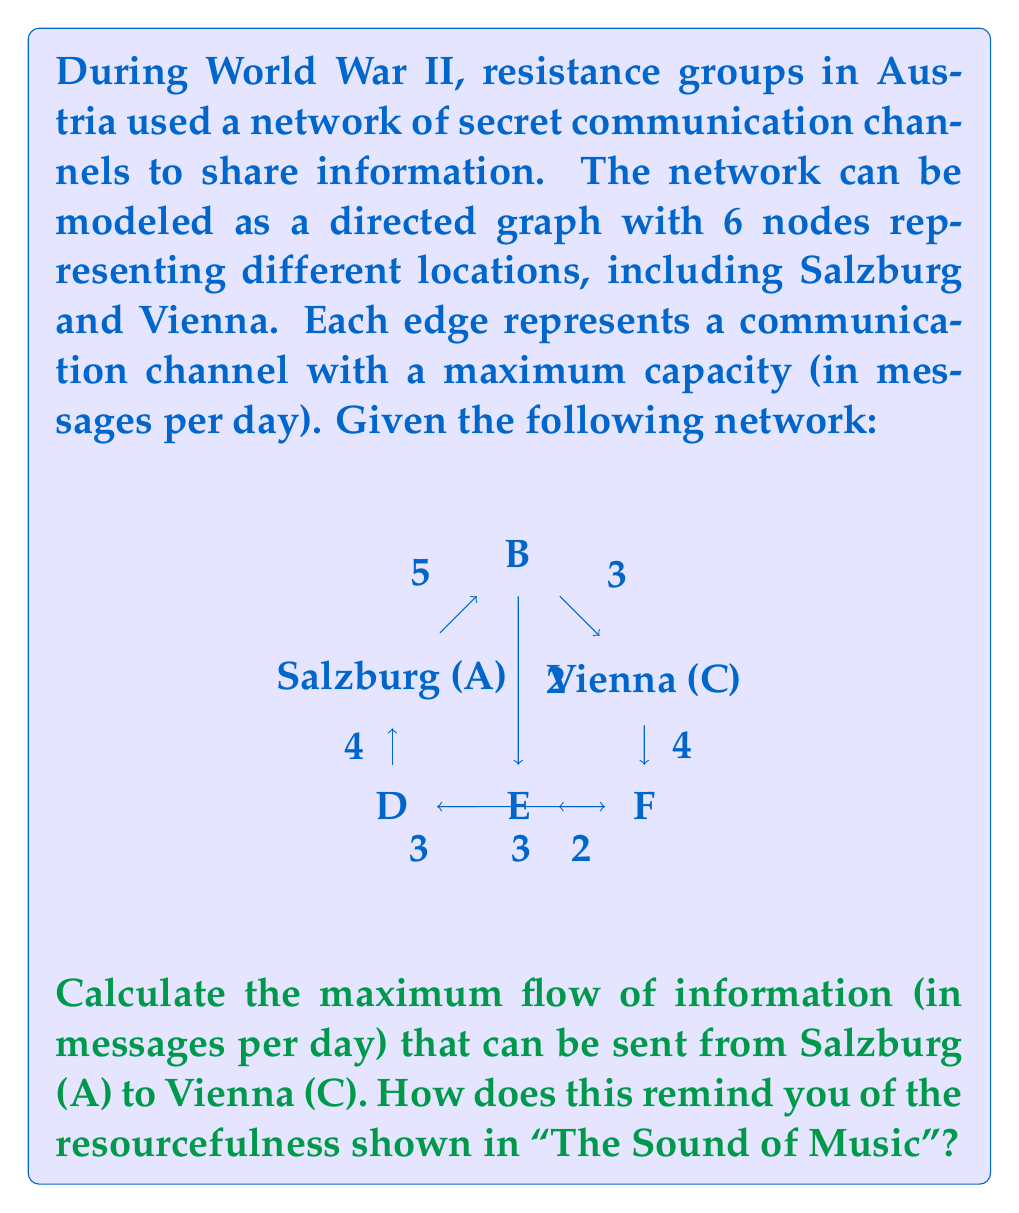Help me with this question. To solve this problem, we'll use the Ford-Fulkerson algorithm to find the maximum flow in the network. This method reminds us of the ingenuity displayed by the von Trapp family in "The Sound of Music" as they found creative ways to overcome obstacles.

Step 1: Initialize the flow to 0 for all edges.

Step 2: Find an augmenting path from Salzburg (A) to Vienna (C). We can use the path A-B-C with a capacity of 3.
Flow after step 2: 3

Step 3: Find another augmenting path. We can use A-D-F-C with a capacity of 3.
Flow after step 3: 3 + 3 = 6

Step 4: Find another augmenting path. We can use A-B-E-F-C with a capacity of 1.
Flow after step 4: 6 + 1 = 7

Step 5: There are no more augmenting paths, so the algorithm terminates.

The maximum flow from Salzburg to Vienna is 7 messages per day. This demonstrates how the resistance groups, like the von Trapps, could creatively use multiple routes to maximize their communication efforts.

To verify this result, we can check the min-cut of the graph:
- Cut 1: {A, B, D} and {C, E, F} with capacity 3 + 4 = 7
- Cut 2: {A, D} and {B, C, E, F} with capacity 5 + 2 = 7

The minimum of these cuts is 7, confirming our max-flow result.
Answer: The maximum flow of information from Salzburg to Vienna is 7 messages per day. 